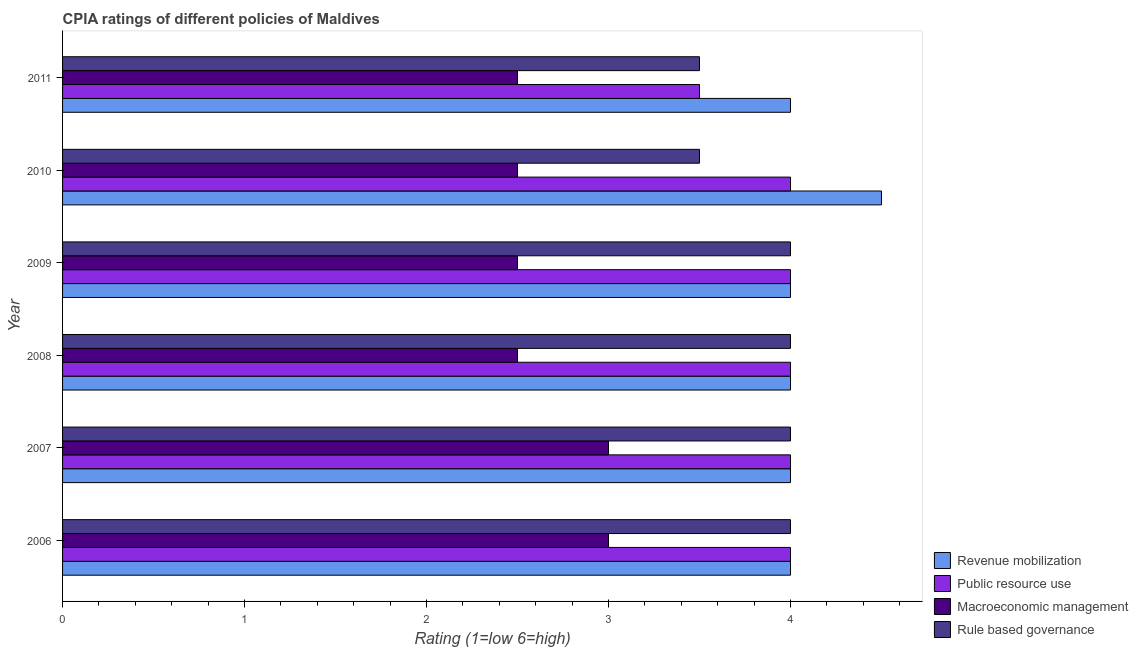Are the number of bars per tick equal to the number of legend labels?
Keep it short and to the point. Yes. Are the number of bars on each tick of the Y-axis equal?
Ensure brevity in your answer.  Yes. How many bars are there on the 5th tick from the bottom?
Ensure brevity in your answer.  4. What is the cpia rating of public resource use in 2006?
Offer a terse response. 4. In which year was the cpia rating of rule based governance maximum?
Make the answer very short. 2006. In which year was the cpia rating of public resource use minimum?
Provide a short and direct response. 2011. What is the total cpia rating of revenue mobilization in the graph?
Your response must be concise. 24.5. What is the difference between the cpia rating of rule based governance in 2009 and that in 2011?
Keep it short and to the point. 0.5. What is the average cpia rating of revenue mobilization per year?
Make the answer very short. 4.08. What is the ratio of the cpia rating of rule based governance in 2007 to that in 2008?
Your answer should be compact. 1. Is the cpia rating of rule based governance in 2006 less than that in 2010?
Your answer should be very brief. No. What is the difference between the highest and the second highest cpia rating of macroeconomic management?
Give a very brief answer. 0. What is the difference between the highest and the lowest cpia rating of macroeconomic management?
Offer a very short reply. 0.5. In how many years, is the cpia rating of macroeconomic management greater than the average cpia rating of macroeconomic management taken over all years?
Make the answer very short. 2. Is the sum of the cpia rating of rule based governance in 2006 and 2010 greater than the maximum cpia rating of revenue mobilization across all years?
Your response must be concise. Yes. Is it the case that in every year, the sum of the cpia rating of public resource use and cpia rating of macroeconomic management is greater than the sum of cpia rating of revenue mobilization and cpia rating of rule based governance?
Your answer should be very brief. No. What does the 2nd bar from the top in 2007 represents?
Make the answer very short. Macroeconomic management. What does the 1st bar from the bottom in 2010 represents?
Provide a short and direct response. Revenue mobilization. Are all the bars in the graph horizontal?
Your answer should be compact. Yes. How many years are there in the graph?
Offer a very short reply. 6. What is the difference between two consecutive major ticks on the X-axis?
Give a very brief answer. 1. Are the values on the major ticks of X-axis written in scientific E-notation?
Keep it short and to the point. No. Does the graph contain grids?
Make the answer very short. No. How many legend labels are there?
Ensure brevity in your answer.  4. What is the title of the graph?
Provide a short and direct response. CPIA ratings of different policies of Maldives. What is the label or title of the Y-axis?
Provide a succinct answer. Year. What is the Rating (1=low 6=high) in Revenue mobilization in 2006?
Offer a very short reply. 4. What is the Rating (1=low 6=high) of Public resource use in 2006?
Your answer should be very brief. 4. What is the Rating (1=low 6=high) in Public resource use in 2007?
Ensure brevity in your answer.  4. What is the Rating (1=low 6=high) of Macroeconomic management in 2007?
Your answer should be very brief. 3. What is the Rating (1=low 6=high) of Macroeconomic management in 2008?
Your answer should be compact. 2.5. What is the Rating (1=low 6=high) in Rule based governance in 2008?
Your answer should be compact. 4. What is the Rating (1=low 6=high) in Macroeconomic management in 2009?
Ensure brevity in your answer.  2.5. What is the Rating (1=low 6=high) in Rule based governance in 2009?
Make the answer very short. 4. What is the Rating (1=low 6=high) of Public resource use in 2010?
Provide a short and direct response. 4. What is the Rating (1=low 6=high) in Macroeconomic management in 2010?
Make the answer very short. 2.5. What is the Rating (1=low 6=high) of Rule based governance in 2010?
Provide a short and direct response. 3.5. What is the Rating (1=low 6=high) in Revenue mobilization in 2011?
Keep it short and to the point. 4. What is the Rating (1=low 6=high) of Rule based governance in 2011?
Ensure brevity in your answer.  3.5. Across all years, what is the maximum Rating (1=low 6=high) in Revenue mobilization?
Offer a very short reply. 4.5. Across all years, what is the maximum Rating (1=low 6=high) in Public resource use?
Provide a short and direct response. 4. Across all years, what is the maximum Rating (1=low 6=high) in Macroeconomic management?
Offer a terse response. 3. Across all years, what is the minimum Rating (1=low 6=high) in Public resource use?
Provide a succinct answer. 3.5. Across all years, what is the minimum Rating (1=low 6=high) of Macroeconomic management?
Make the answer very short. 2.5. What is the total Rating (1=low 6=high) in Revenue mobilization in the graph?
Make the answer very short. 24.5. What is the total Rating (1=low 6=high) of Public resource use in the graph?
Offer a terse response. 23.5. What is the total Rating (1=low 6=high) in Rule based governance in the graph?
Ensure brevity in your answer.  23. What is the difference between the Rating (1=low 6=high) in Public resource use in 2006 and that in 2007?
Make the answer very short. 0. What is the difference between the Rating (1=low 6=high) of Macroeconomic management in 2006 and that in 2007?
Your response must be concise. 0. What is the difference between the Rating (1=low 6=high) of Rule based governance in 2006 and that in 2007?
Your answer should be very brief. 0. What is the difference between the Rating (1=low 6=high) of Revenue mobilization in 2006 and that in 2008?
Offer a very short reply. 0. What is the difference between the Rating (1=low 6=high) of Public resource use in 2006 and that in 2008?
Your answer should be compact. 0. What is the difference between the Rating (1=low 6=high) in Macroeconomic management in 2006 and that in 2008?
Give a very brief answer. 0.5. What is the difference between the Rating (1=low 6=high) of Revenue mobilization in 2006 and that in 2009?
Provide a succinct answer. 0. What is the difference between the Rating (1=low 6=high) of Public resource use in 2006 and that in 2009?
Provide a succinct answer. 0. What is the difference between the Rating (1=low 6=high) of Public resource use in 2006 and that in 2010?
Offer a very short reply. 0. What is the difference between the Rating (1=low 6=high) of Rule based governance in 2006 and that in 2010?
Your answer should be very brief. 0.5. What is the difference between the Rating (1=low 6=high) of Macroeconomic management in 2006 and that in 2011?
Your answer should be compact. 0.5. What is the difference between the Rating (1=low 6=high) of Rule based governance in 2006 and that in 2011?
Provide a short and direct response. 0.5. What is the difference between the Rating (1=low 6=high) in Rule based governance in 2007 and that in 2008?
Your response must be concise. 0. What is the difference between the Rating (1=low 6=high) in Revenue mobilization in 2007 and that in 2009?
Provide a succinct answer. 0. What is the difference between the Rating (1=low 6=high) of Rule based governance in 2007 and that in 2009?
Offer a very short reply. 0. What is the difference between the Rating (1=low 6=high) of Revenue mobilization in 2007 and that in 2010?
Your response must be concise. -0.5. What is the difference between the Rating (1=low 6=high) of Public resource use in 2007 and that in 2010?
Ensure brevity in your answer.  0. What is the difference between the Rating (1=low 6=high) in Rule based governance in 2007 and that in 2010?
Provide a short and direct response. 0.5. What is the difference between the Rating (1=low 6=high) of Macroeconomic management in 2007 and that in 2011?
Your answer should be compact. 0.5. What is the difference between the Rating (1=low 6=high) in Revenue mobilization in 2008 and that in 2009?
Make the answer very short. 0. What is the difference between the Rating (1=low 6=high) in Public resource use in 2008 and that in 2009?
Your response must be concise. 0. What is the difference between the Rating (1=low 6=high) of Revenue mobilization in 2008 and that in 2011?
Keep it short and to the point. 0. What is the difference between the Rating (1=low 6=high) in Macroeconomic management in 2008 and that in 2011?
Make the answer very short. 0. What is the difference between the Rating (1=low 6=high) in Rule based governance in 2008 and that in 2011?
Offer a terse response. 0.5. What is the difference between the Rating (1=low 6=high) in Revenue mobilization in 2009 and that in 2010?
Keep it short and to the point. -0.5. What is the difference between the Rating (1=low 6=high) of Public resource use in 2009 and that in 2010?
Your response must be concise. 0. What is the difference between the Rating (1=low 6=high) of Rule based governance in 2009 and that in 2010?
Ensure brevity in your answer.  0.5. What is the difference between the Rating (1=low 6=high) in Public resource use in 2009 and that in 2011?
Your answer should be compact. 0.5. What is the difference between the Rating (1=low 6=high) in Revenue mobilization in 2010 and that in 2011?
Make the answer very short. 0.5. What is the difference between the Rating (1=low 6=high) in Macroeconomic management in 2010 and that in 2011?
Make the answer very short. 0. What is the difference between the Rating (1=low 6=high) in Revenue mobilization in 2006 and the Rating (1=low 6=high) in Public resource use in 2007?
Give a very brief answer. 0. What is the difference between the Rating (1=low 6=high) of Revenue mobilization in 2006 and the Rating (1=low 6=high) of Macroeconomic management in 2007?
Provide a succinct answer. 1. What is the difference between the Rating (1=low 6=high) in Revenue mobilization in 2006 and the Rating (1=low 6=high) in Rule based governance in 2007?
Your answer should be compact. 0. What is the difference between the Rating (1=low 6=high) of Public resource use in 2006 and the Rating (1=low 6=high) of Macroeconomic management in 2007?
Ensure brevity in your answer.  1. What is the difference between the Rating (1=low 6=high) in Revenue mobilization in 2006 and the Rating (1=low 6=high) in Public resource use in 2008?
Make the answer very short. 0. What is the difference between the Rating (1=low 6=high) of Revenue mobilization in 2006 and the Rating (1=low 6=high) of Macroeconomic management in 2008?
Make the answer very short. 1.5. What is the difference between the Rating (1=low 6=high) in Revenue mobilization in 2006 and the Rating (1=low 6=high) in Rule based governance in 2008?
Offer a terse response. 0. What is the difference between the Rating (1=low 6=high) of Public resource use in 2006 and the Rating (1=low 6=high) of Macroeconomic management in 2008?
Ensure brevity in your answer.  1.5. What is the difference between the Rating (1=low 6=high) of Revenue mobilization in 2006 and the Rating (1=low 6=high) of Rule based governance in 2009?
Offer a terse response. 0. What is the difference between the Rating (1=low 6=high) in Public resource use in 2006 and the Rating (1=low 6=high) in Rule based governance in 2009?
Offer a very short reply. 0. What is the difference between the Rating (1=low 6=high) of Revenue mobilization in 2006 and the Rating (1=low 6=high) of Public resource use in 2010?
Offer a terse response. 0. What is the difference between the Rating (1=low 6=high) of Revenue mobilization in 2006 and the Rating (1=low 6=high) of Macroeconomic management in 2010?
Give a very brief answer. 1.5. What is the difference between the Rating (1=low 6=high) in Public resource use in 2006 and the Rating (1=low 6=high) in Rule based governance in 2010?
Give a very brief answer. 0.5. What is the difference between the Rating (1=low 6=high) of Macroeconomic management in 2006 and the Rating (1=low 6=high) of Rule based governance in 2010?
Provide a succinct answer. -0.5. What is the difference between the Rating (1=low 6=high) of Revenue mobilization in 2006 and the Rating (1=low 6=high) of Public resource use in 2011?
Your response must be concise. 0.5. What is the difference between the Rating (1=low 6=high) in Public resource use in 2006 and the Rating (1=low 6=high) in Macroeconomic management in 2011?
Offer a very short reply. 1.5. What is the difference between the Rating (1=low 6=high) of Macroeconomic management in 2006 and the Rating (1=low 6=high) of Rule based governance in 2011?
Offer a very short reply. -0.5. What is the difference between the Rating (1=low 6=high) in Revenue mobilization in 2007 and the Rating (1=low 6=high) in Public resource use in 2008?
Provide a succinct answer. 0. What is the difference between the Rating (1=low 6=high) of Revenue mobilization in 2007 and the Rating (1=low 6=high) of Rule based governance in 2008?
Offer a very short reply. 0. What is the difference between the Rating (1=low 6=high) of Public resource use in 2007 and the Rating (1=low 6=high) of Macroeconomic management in 2008?
Keep it short and to the point. 1.5. What is the difference between the Rating (1=low 6=high) in Revenue mobilization in 2007 and the Rating (1=low 6=high) in Macroeconomic management in 2009?
Keep it short and to the point. 1.5. What is the difference between the Rating (1=low 6=high) in Public resource use in 2007 and the Rating (1=low 6=high) in Rule based governance in 2009?
Your answer should be very brief. 0. What is the difference between the Rating (1=low 6=high) of Revenue mobilization in 2007 and the Rating (1=low 6=high) of Public resource use in 2010?
Keep it short and to the point. 0. What is the difference between the Rating (1=low 6=high) of Revenue mobilization in 2007 and the Rating (1=low 6=high) of Rule based governance in 2010?
Ensure brevity in your answer.  0.5. What is the difference between the Rating (1=low 6=high) of Public resource use in 2007 and the Rating (1=low 6=high) of Macroeconomic management in 2010?
Make the answer very short. 1.5. What is the difference between the Rating (1=low 6=high) in Revenue mobilization in 2007 and the Rating (1=low 6=high) in Rule based governance in 2011?
Your answer should be compact. 0.5. What is the difference between the Rating (1=low 6=high) in Public resource use in 2007 and the Rating (1=low 6=high) in Macroeconomic management in 2011?
Keep it short and to the point. 1.5. What is the difference between the Rating (1=low 6=high) of Revenue mobilization in 2008 and the Rating (1=low 6=high) of Public resource use in 2009?
Your response must be concise. 0. What is the difference between the Rating (1=low 6=high) in Revenue mobilization in 2008 and the Rating (1=low 6=high) in Rule based governance in 2009?
Keep it short and to the point. 0. What is the difference between the Rating (1=low 6=high) in Public resource use in 2008 and the Rating (1=low 6=high) in Macroeconomic management in 2009?
Keep it short and to the point. 1.5. What is the difference between the Rating (1=low 6=high) in Macroeconomic management in 2008 and the Rating (1=low 6=high) in Rule based governance in 2009?
Keep it short and to the point. -1.5. What is the difference between the Rating (1=low 6=high) in Revenue mobilization in 2008 and the Rating (1=low 6=high) in Macroeconomic management in 2010?
Make the answer very short. 1.5. What is the difference between the Rating (1=low 6=high) of Revenue mobilization in 2008 and the Rating (1=low 6=high) of Rule based governance in 2010?
Offer a very short reply. 0.5. What is the difference between the Rating (1=low 6=high) of Public resource use in 2008 and the Rating (1=low 6=high) of Macroeconomic management in 2010?
Ensure brevity in your answer.  1.5. What is the difference between the Rating (1=low 6=high) in Public resource use in 2008 and the Rating (1=low 6=high) in Rule based governance in 2010?
Provide a succinct answer. 0.5. What is the difference between the Rating (1=low 6=high) in Revenue mobilization in 2008 and the Rating (1=low 6=high) in Macroeconomic management in 2011?
Your response must be concise. 1.5. What is the difference between the Rating (1=low 6=high) of Public resource use in 2008 and the Rating (1=low 6=high) of Rule based governance in 2011?
Ensure brevity in your answer.  0.5. What is the difference between the Rating (1=low 6=high) of Revenue mobilization in 2009 and the Rating (1=low 6=high) of Macroeconomic management in 2010?
Keep it short and to the point. 1.5. What is the difference between the Rating (1=low 6=high) of Revenue mobilization in 2009 and the Rating (1=low 6=high) of Rule based governance in 2010?
Offer a terse response. 0.5. What is the difference between the Rating (1=low 6=high) in Public resource use in 2009 and the Rating (1=low 6=high) in Macroeconomic management in 2011?
Provide a succinct answer. 1.5. What is the difference between the Rating (1=low 6=high) of Public resource use in 2009 and the Rating (1=low 6=high) of Rule based governance in 2011?
Your answer should be very brief. 0.5. What is the difference between the Rating (1=low 6=high) in Revenue mobilization in 2010 and the Rating (1=low 6=high) in Public resource use in 2011?
Provide a succinct answer. 1. What is the difference between the Rating (1=low 6=high) of Revenue mobilization in 2010 and the Rating (1=low 6=high) of Macroeconomic management in 2011?
Ensure brevity in your answer.  2. What is the average Rating (1=low 6=high) in Revenue mobilization per year?
Keep it short and to the point. 4.08. What is the average Rating (1=low 6=high) in Public resource use per year?
Offer a terse response. 3.92. What is the average Rating (1=low 6=high) of Macroeconomic management per year?
Keep it short and to the point. 2.67. What is the average Rating (1=low 6=high) of Rule based governance per year?
Provide a short and direct response. 3.83. In the year 2006, what is the difference between the Rating (1=low 6=high) in Revenue mobilization and Rating (1=low 6=high) in Macroeconomic management?
Give a very brief answer. 1. In the year 2006, what is the difference between the Rating (1=low 6=high) in Public resource use and Rating (1=low 6=high) in Macroeconomic management?
Your response must be concise. 1. In the year 2006, what is the difference between the Rating (1=low 6=high) in Public resource use and Rating (1=low 6=high) in Rule based governance?
Ensure brevity in your answer.  0. In the year 2006, what is the difference between the Rating (1=low 6=high) of Macroeconomic management and Rating (1=low 6=high) of Rule based governance?
Offer a very short reply. -1. In the year 2007, what is the difference between the Rating (1=low 6=high) of Revenue mobilization and Rating (1=low 6=high) of Public resource use?
Your response must be concise. 0. In the year 2007, what is the difference between the Rating (1=low 6=high) of Revenue mobilization and Rating (1=low 6=high) of Macroeconomic management?
Your answer should be compact. 1. In the year 2007, what is the difference between the Rating (1=low 6=high) in Revenue mobilization and Rating (1=low 6=high) in Rule based governance?
Your answer should be compact. 0. In the year 2007, what is the difference between the Rating (1=low 6=high) of Public resource use and Rating (1=low 6=high) of Rule based governance?
Your response must be concise. 0. In the year 2008, what is the difference between the Rating (1=low 6=high) in Revenue mobilization and Rating (1=low 6=high) in Public resource use?
Provide a short and direct response. 0. In the year 2008, what is the difference between the Rating (1=low 6=high) in Revenue mobilization and Rating (1=low 6=high) in Macroeconomic management?
Give a very brief answer. 1.5. In the year 2008, what is the difference between the Rating (1=low 6=high) in Public resource use and Rating (1=low 6=high) in Macroeconomic management?
Offer a terse response. 1.5. In the year 2008, what is the difference between the Rating (1=low 6=high) of Macroeconomic management and Rating (1=low 6=high) of Rule based governance?
Your response must be concise. -1.5. In the year 2009, what is the difference between the Rating (1=low 6=high) of Public resource use and Rating (1=low 6=high) of Rule based governance?
Make the answer very short. 0. In the year 2009, what is the difference between the Rating (1=low 6=high) of Macroeconomic management and Rating (1=low 6=high) of Rule based governance?
Provide a succinct answer. -1.5. In the year 2010, what is the difference between the Rating (1=low 6=high) in Revenue mobilization and Rating (1=low 6=high) in Rule based governance?
Your answer should be very brief. 1. In the year 2010, what is the difference between the Rating (1=low 6=high) in Public resource use and Rating (1=low 6=high) in Macroeconomic management?
Give a very brief answer. 1.5. In the year 2010, what is the difference between the Rating (1=low 6=high) of Macroeconomic management and Rating (1=low 6=high) of Rule based governance?
Provide a short and direct response. -1. In the year 2011, what is the difference between the Rating (1=low 6=high) of Revenue mobilization and Rating (1=low 6=high) of Public resource use?
Your response must be concise. 0.5. In the year 2011, what is the difference between the Rating (1=low 6=high) in Revenue mobilization and Rating (1=low 6=high) in Macroeconomic management?
Provide a short and direct response. 1.5. In the year 2011, what is the difference between the Rating (1=low 6=high) of Public resource use and Rating (1=low 6=high) of Rule based governance?
Give a very brief answer. 0. In the year 2011, what is the difference between the Rating (1=low 6=high) of Macroeconomic management and Rating (1=low 6=high) of Rule based governance?
Offer a very short reply. -1. What is the ratio of the Rating (1=low 6=high) of Revenue mobilization in 2006 to that in 2007?
Provide a short and direct response. 1. What is the ratio of the Rating (1=low 6=high) in Revenue mobilization in 2006 to that in 2008?
Provide a succinct answer. 1. What is the ratio of the Rating (1=low 6=high) of Public resource use in 2006 to that in 2008?
Your answer should be very brief. 1. What is the ratio of the Rating (1=low 6=high) of Macroeconomic management in 2006 to that in 2008?
Provide a short and direct response. 1.2. What is the ratio of the Rating (1=low 6=high) in Rule based governance in 2006 to that in 2008?
Make the answer very short. 1. What is the ratio of the Rating (1=low 6=high) of Revenue mobilization in 2006 to that in 2009?
Keep it short and to the point. 1. What is the ratio of the Rating (1=low 6=high) of Public resource use in 2006 to that in 2009?
Offer a terse response. 1. What is the ratio of the Rating (1=low 6=high) of Rule based governance in 2006 to that in 2009?
Offer a terse response. 1. What is the ratio of the Rating (1=low 6=high) of Revenue mobilization in 2006 to that in 2010?
Ensure brevity in your answer.  0.89. What is the ratio of the Rating (1=low 6=high) in Public resource use in 2006 to that in 2010?
Keep it short and to the point. 1. What is the ratio of the Rating (1=low 6=high) in Macroeconomic management in 2006 to that in 2010?
Offer a very short reply. 1.2. What is the ratio of the Rating (1=low 6=high) in Revenue mobilization in 2007 to that in 2008?
Give a very brief answer. 1. What is the ratio of the Rating (1=low 6=high) of Macroeconomic management in 2007 to that in 2008?
Your answer should be compact. 1.2. What is the ratio of the Rating (1=low 6=high) in Rule based governance in 2007 to that in 2008?
Your answer should be very brief. 1. What is the ratio of the Rating (1=low 6=high) in Revenue mobilization in 2007 to that in 2009?
Keep it short and to the point. 1. What is the ratio of the Rating (1=low 6=high) of Public resource use in 2007 to that in 2009?
Ensure brevity in your answer.  1. What is the ratio of the Rating (1=low 6=high) in Macroeconomic management in 2007 to that in 2009?
Make the answer very short. 1.2. What is the ratio of the Rating (1=low 6=high) in Rule based governance in 2007 to that in 2009?
Offer a very short reply. 1. What is the ratio of the Rating (1=low 6=high) in Revenue mobilization in 2007 to that in 2010?
Provide a short and direct response. 0.89. What is the ratio of the Rating (1=low 6=high) of Macroeconomic management in 2007 to that in 2010?
Your answer should be compact. 1.2. What is the ratio of the Rating (1=low 6=high) of Public resource use in 2007 to that in 2011?
Give a very brief answer. 1.14. What is the ratio of the Rating (1=low 6=high) of Rule based governance in 2007 to that in 2011?
Give a very brief answer. 1.14. What is the ratio of the Rating (1=low 6=high) in Macroeconomic management in 2008 to that in 2009?
Give a very brief answer. 1. What is the ratio of the Rating (1=low 6=high) of Public resource use in 2008 to that in 2010?
Offer a very short reply. 1. What is the ratio of the Rating (1=low 6=high) of Revenue mobilization in 2008 to that in 2011?
Your answer should be very brief. 1. What is the ratio of the Rating (1=low 6=high) in Rule based governance in 2008 to that in 2011?
Offer a very short reply. 1.14. What is the ratio of the Rating (1=low 6=high) of Revenue mobilization in 2009 to that in 2010?
Your response must be concise. 0.89. What is the ratio of the Rating (1=low 6=high) in Public resource use in 2009 to that in 2010?
Your response must be concise. 1. What is the ratio of the Rating (1=low 6=high) of Revenue mobilization in 2009 to that in 2011?
Ensure brevity in your answer.  1. What is the ratio of the Rating (1=low 6=high) of Revenue mobilization in 2010 to that in 2011?
Your answer should be compact. 1.12. What is the ratio of the Rating (1=low 6=high) of Public resource use in 2010 to that in 2011?
Your answer should be very brief. 1.14. What is the ratio of the Rating (1=low 6=high) in Rule based governance in 2010 to that in 2011?
Your response must be concise. 1. What is the difference between the highest and the second highest Rating (1=low 6=high) of Public resource use?
Provide a succinct answer. 0. What is the difference between the highest and the second highest Rating (1=low 6=high) in Rule based governance?
Provide a short and direct response. 0. 